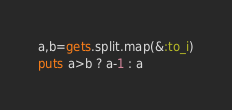<code> <loc_0><loc_0><loc_500><loc_500><_Ruby_>a,b=gets.split.map(&:to_i)
puts a>b ? a-1 : a</code> 